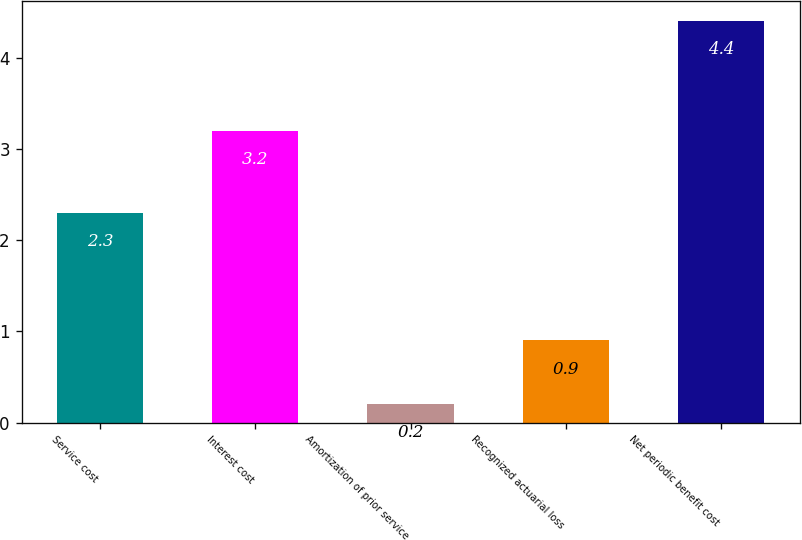Convert chart to OTSL. <chart><loc_0><loc_0><loc_500><loc_500><bar_chart><fcel>Service cost<fcel>Interest cost<fcel>Amortization of prior service<fcel>Recognized actuarial loss<fcel>Net periodic benefit cost<nl><fcel>2.3<fcel>3.2<fcel>0.2<fcel>0.9<fcel>4.4<nl></chart> 